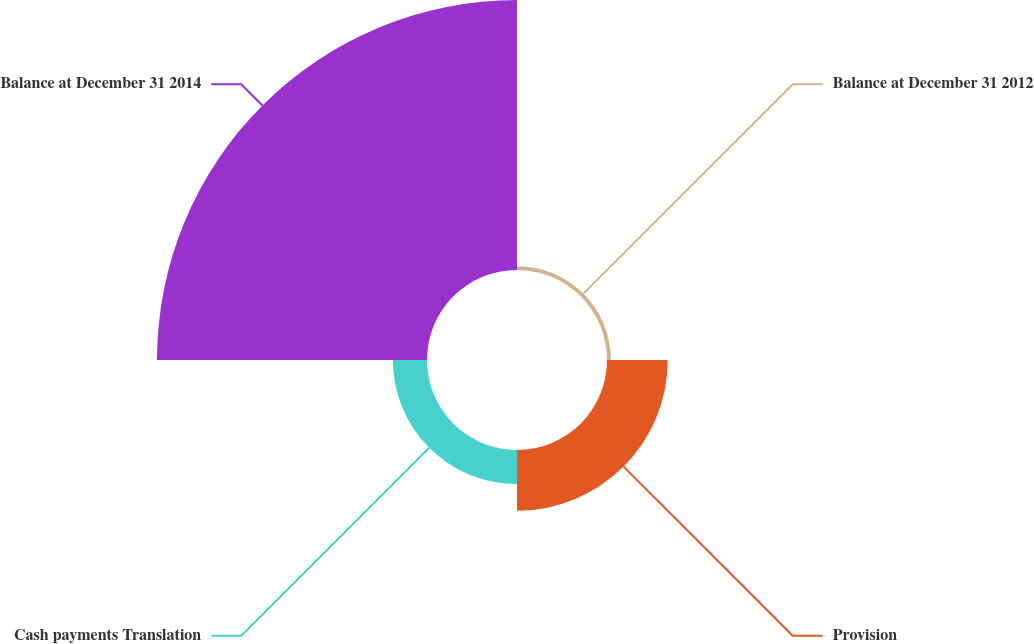Convert chart to OTSL. <chart><loc_0><loc_0><loc_500><loc_500><pie_chart><fcel>Balance at December 31 2012<fcel>Provision<fcel>Cash payments Translation<fcel>Balance at December 31 2014<nl><fcel>1.05%<fcel>16.48%<fcel>9.26%<fcel>73.21%<nl></chart> 